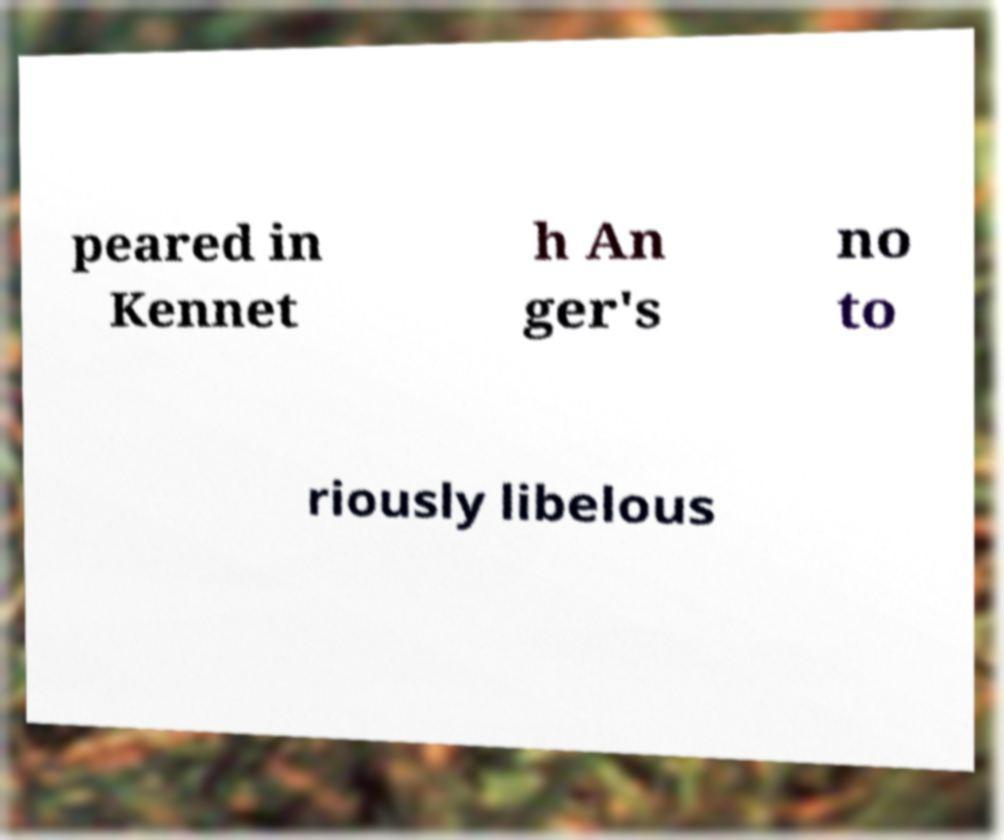Could you extract and type out the text from this image? peared in Kennet h An ger's no to riously libelous 